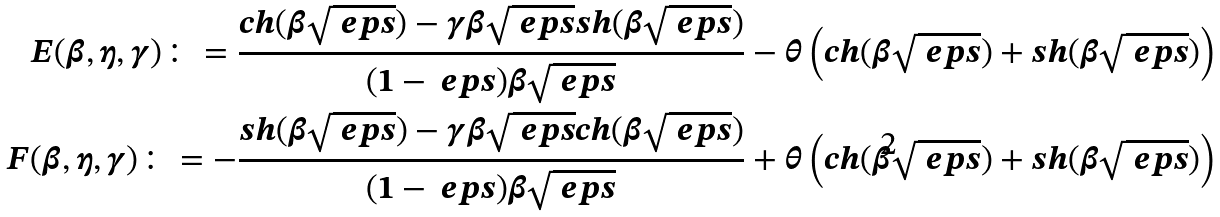Convert formula to latex. <formula><loc_0><loc_0><loc_500><loc_500>E ( \beta , \eta , \gamma ) \colon = \frac { c h ( \beta \sqrt { \ e p s } ) - \gamma \beta \sqrt { \ e p s } s h ( \beta \sqrt { \ e p s } ) } { ( 1 - \ e p s ) \beta \sqrt { \ e p s } } - \theta \left ( c h ( \beta \sqrt { \ e p s } ) + s h ( \beta \sqrt { \ e p s } ) \right ) \\ F ( \beta , \eta , \gamma ) \colon = - \frac { s h ( \beta \sqrt { \ e p s } ) - \gamma \beta \sqrt { \ e p s } c h ( \beta \sqrt { \ e p s } ) } { ( 1 - \ e p s ) \beta \sqrt { \ e p s } } + \theta \left ( c h ( \beta \sqrt { \ e p s } ) + s h ( \beta \sqrt { \ e p s } ) \right )</formula> 